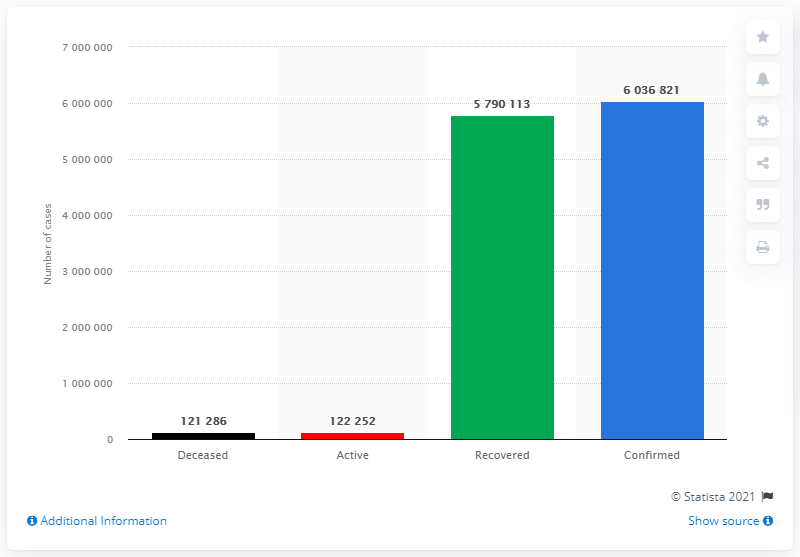List a handful of essential elements in this visual. The number of recovered cases is 57,901,300. The category with the highest value has been confirmed. As of February 2023, it is estimated that 121,286 people have died from COVID-19. 